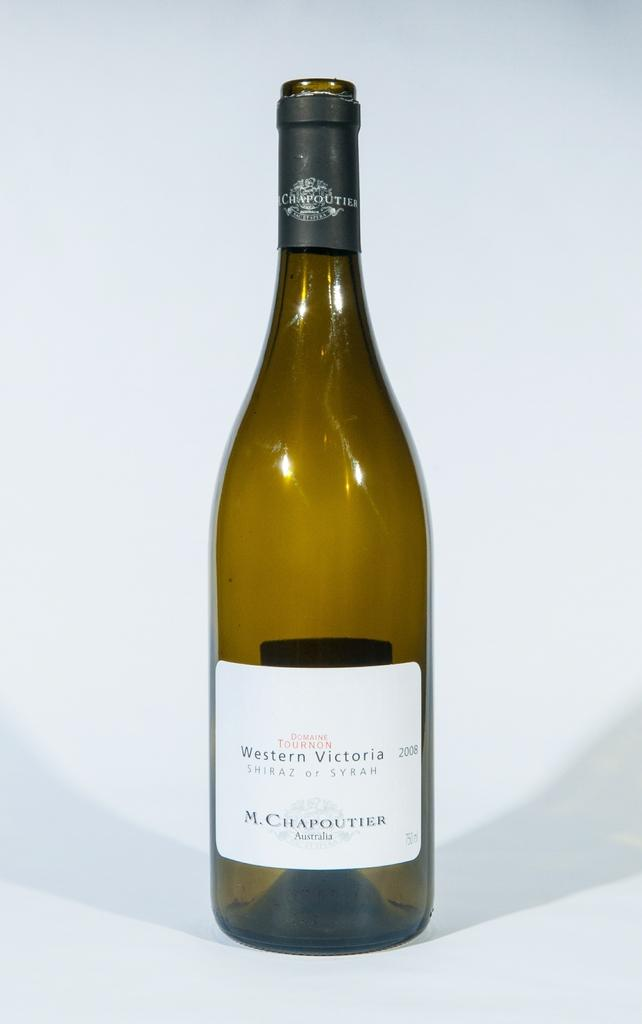Provide a one-sentence caption for the provided image. An empty bottle of Syrah from Western Victoria. 